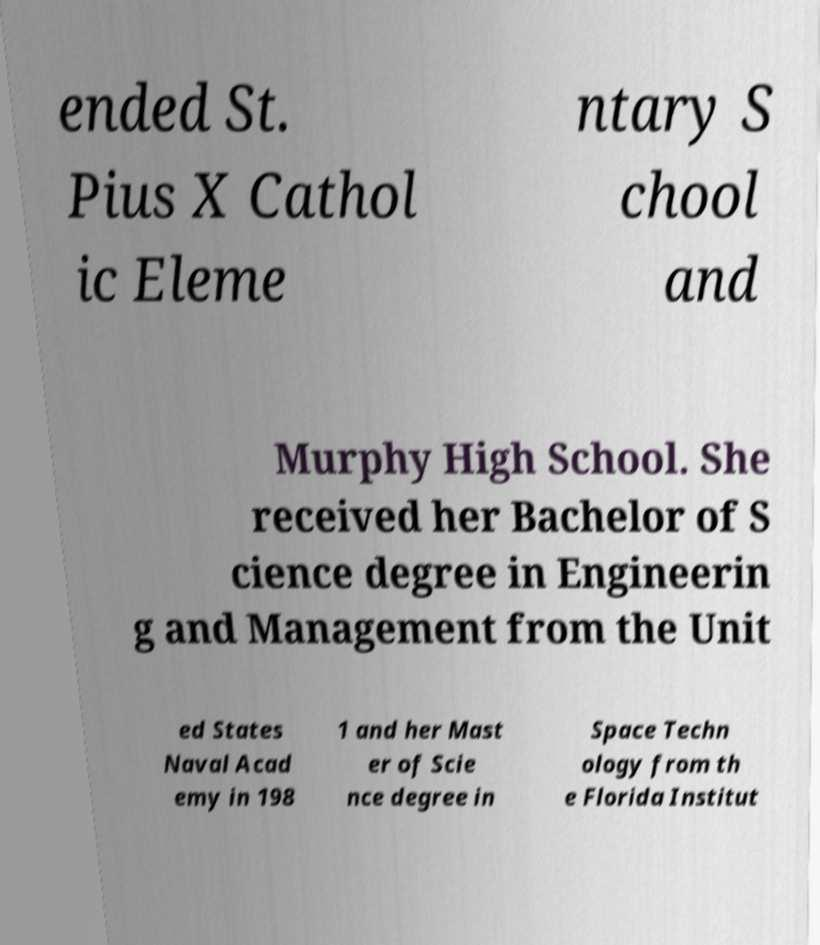Please identify and transcribe the text found in this image. ended St. Pius X Cathol ic Eleme ntary S chool and Murphy High School. She received her Bachelor of S cience degree in Engineerin g and Management from the Unit ed States Naval Acad emy in 198 1 and her Mast er of Scie nce degree in Space Techn ology from th e Florida Institut 